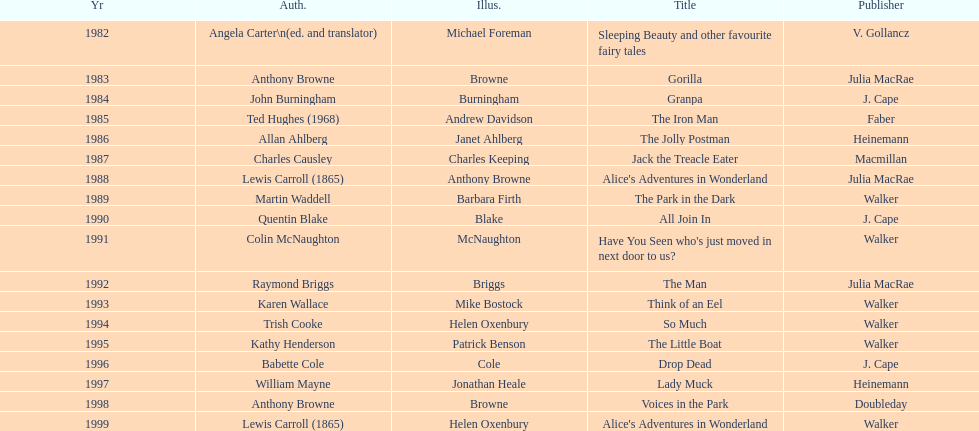What is the only title listed for 1999? Alice's Adventures in Wonderland. 